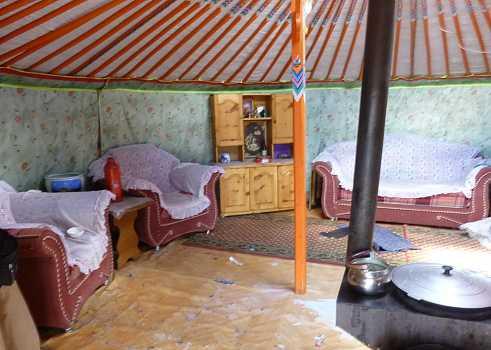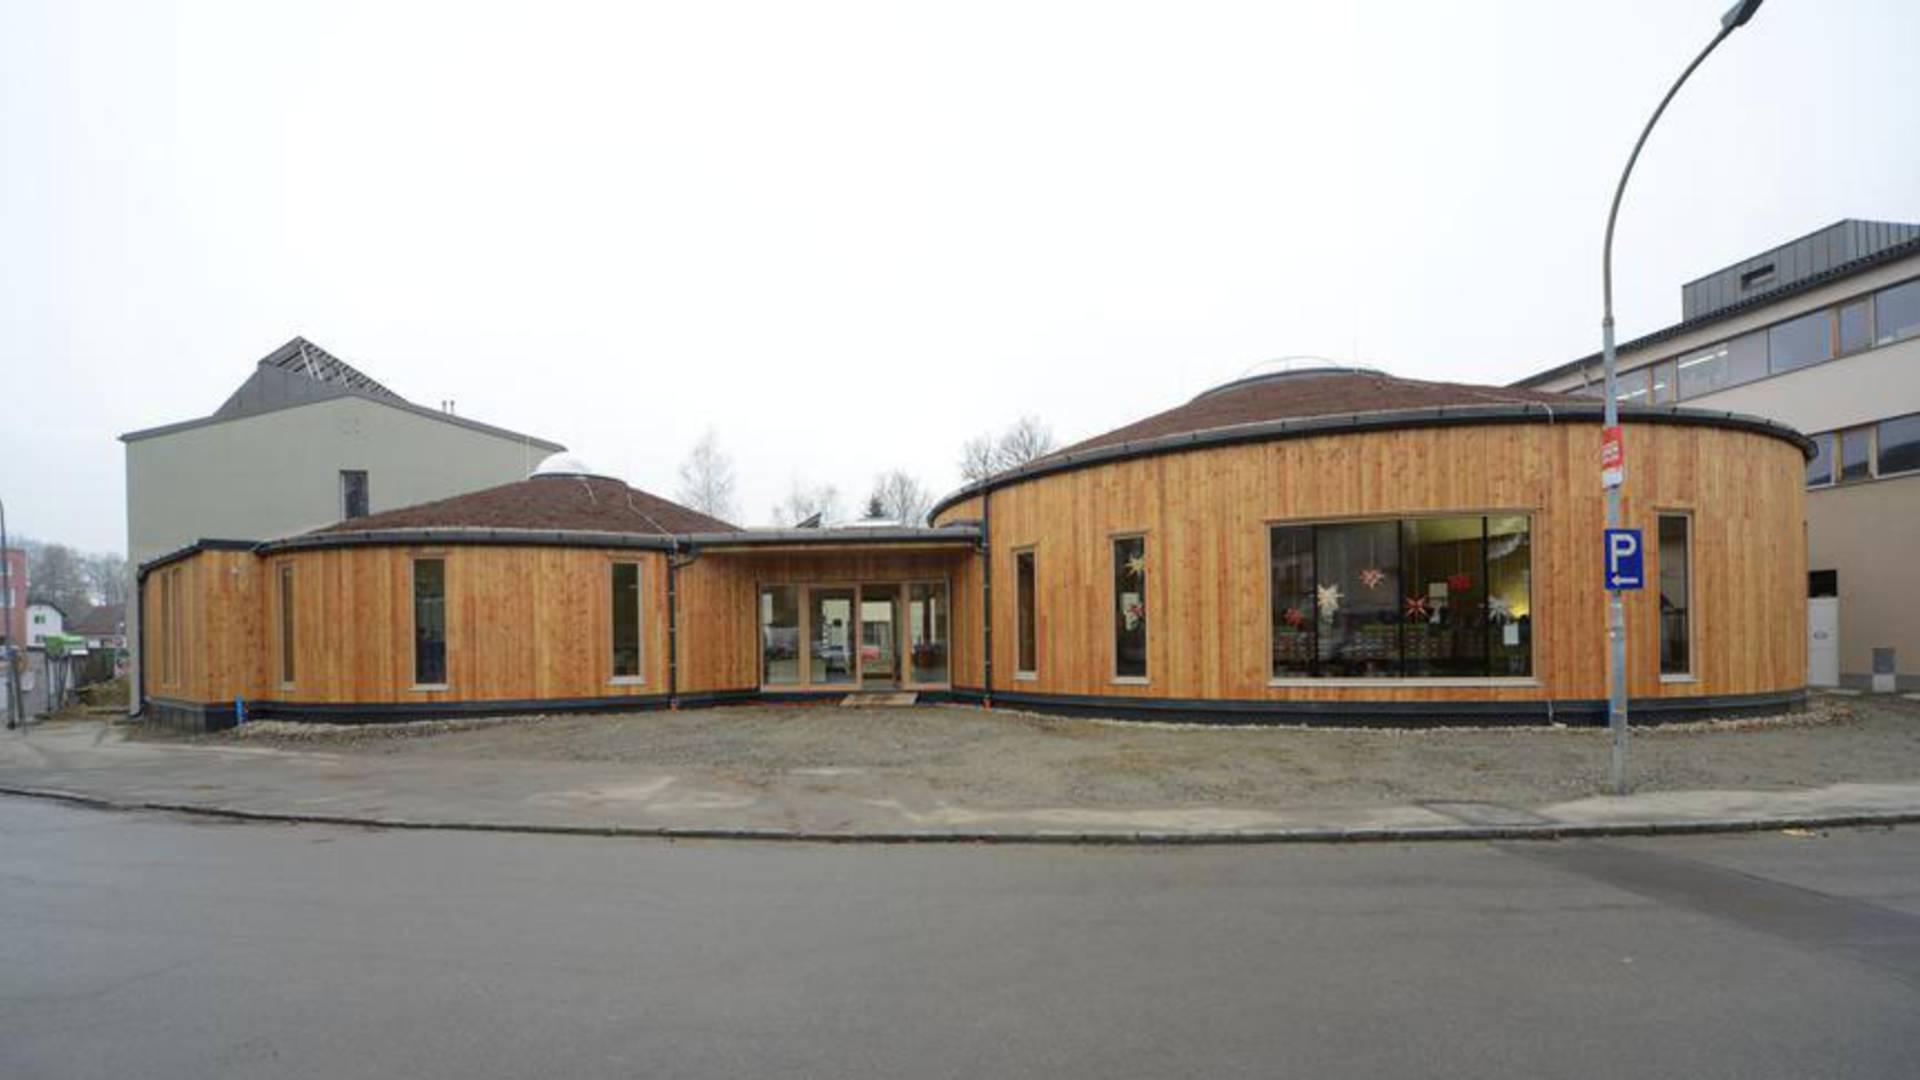The first image is the image on the left, the second image is the image on the right. Considering the images on both sides, is "One of the images contains the exterior of a yurt." valid? Answer yes or no. Yes. The first image is the image on the left, the second image is the image on the right. Examine the images to the left and right. Is the description "The left image features at least one plant with long green leaves near something resembling a table." accurate? Answer yes or no. No. 